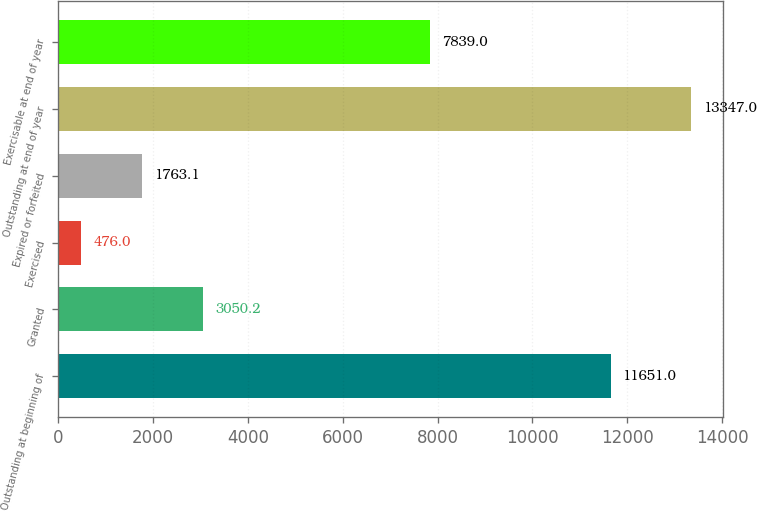Convert chart. <chart><loc_0><loc_0><loc_500><loc_500><bar_chart><fcel>Outstanding at beginning of<fcel>Granted<fcel>Exercised<fcel>Expired or forfeited<fcel>Outstanding at end of year<fcel>Exercisable at end of year<nl><fcel>11651<fcel>3050.2<fcel>476<fcel>1763.1<fcel>13347<fcel>7839<nl></chart> 